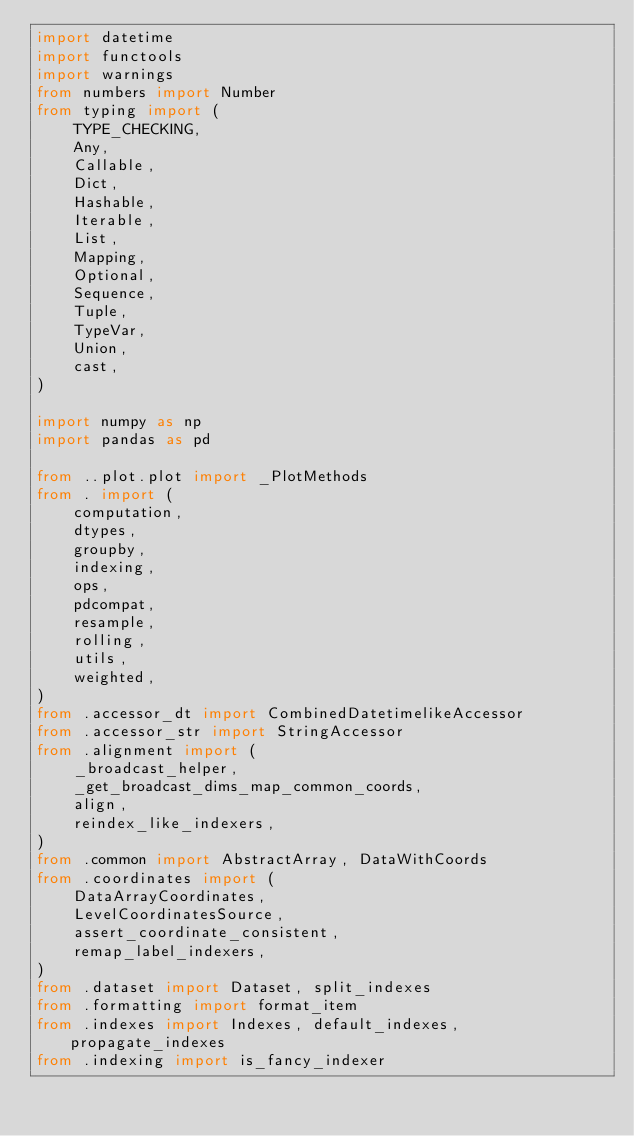Convert code to text. <code><loc_0><loc_0><loc_500><loc_500><_Python_>import datetime
import functools
import warnings
from numbers import Number
from typing import (
    TYPE_CHECKING,
    Any,
    Callable,
    Dict,
    Hashable,
    Iterable,
    List,
    Mapping,
    Optional,
    Sequence,
    Tuple,
    TypeVar,
    Union,
    cast,
)

import numpy as np
import pandas as pd

from ..plot.plot import _PlotMethods
from . import (
    computation,
    dtypes,
    groupby,
    indexing,
    ops,
    pdcompat,
    resample,
    rolling,
    utils,
    weighted,
)
from .accessor_dt import CombinedDatetimelikeAccessor
from .accessor_str import StringAccessor
from .alignment import (
    _broadcast_helper,
    _get_broadcast_dims_map_common_coords,
    align,
    reindex_like_indexers,
)
from .common import AbstractArray, DataWithCoords
from .coordinates import (
    DataArrayCoordinates,
    LevelCoordinatesSource,
    assert_coordinate_consistent,
    remap_label_indexers,
)
from .dataset import Dataset, split_indexes
from .formatting import format_item
from .indexes import Indexes, default_indexes, propagate_indexes
from .indexing import is_fancy_indexer</code> 